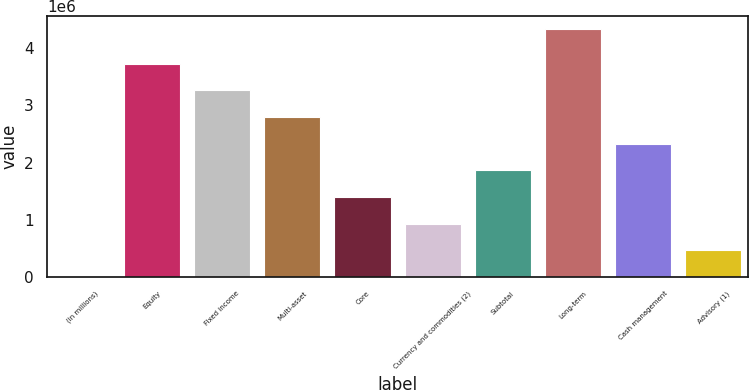Convert chart to OTSL. <chart><loc_0><loc_0><loc_500><loc_500><bar_chart><fcel>(in millions)<fcel>Equity<fcel>Fixed income<fcel>Multi-asset<fcel>Core<fcel>Currency and commodities (2)<fcel>Subtotal<fcel>Long-term<fcel>Cash management<fcel>Advisory (1)<nl><fcel>2014<fcel>3.72192e+06<fcel>3.25693e+06<fcel>2.79194e+06<fcel>1.39698e+06<fcel>931990<fcel>1.86197e+06<fcel>4.33384e+06<fcel>2.32695e+06<fcel>467002<nl></chart> 